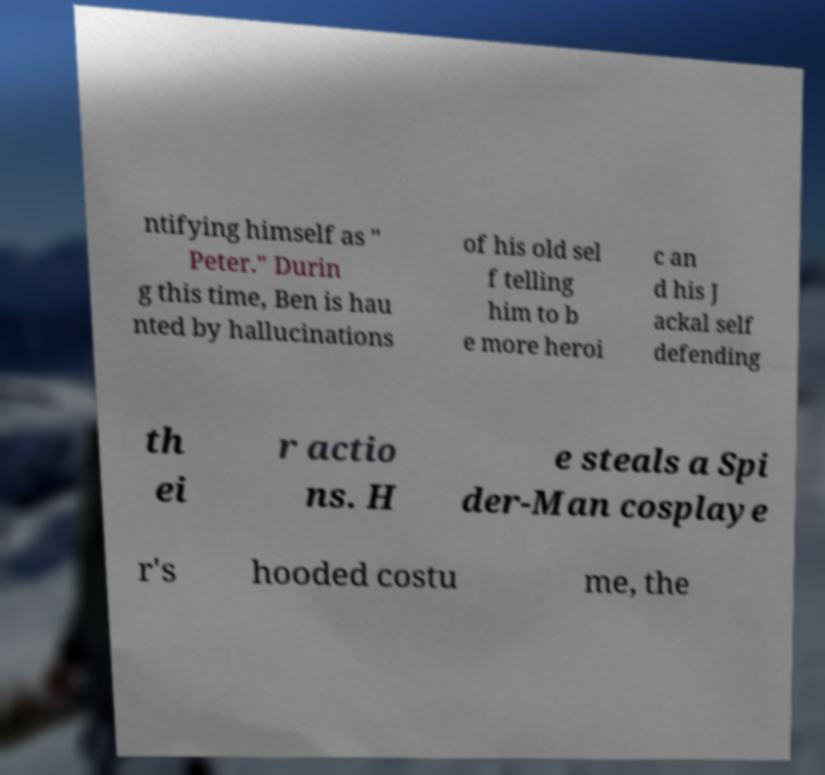I need the written content from this picture converted into text. Can you do that? ntifying himself as " Peter." Durin g this time, Ben is hau nted by hallucinations of his old sel f telling him to b e more heroi c an d his J ackal self defending th ei r actio ns. H e steals a Spi der-Man cosplaye r's hooded costu me, the 